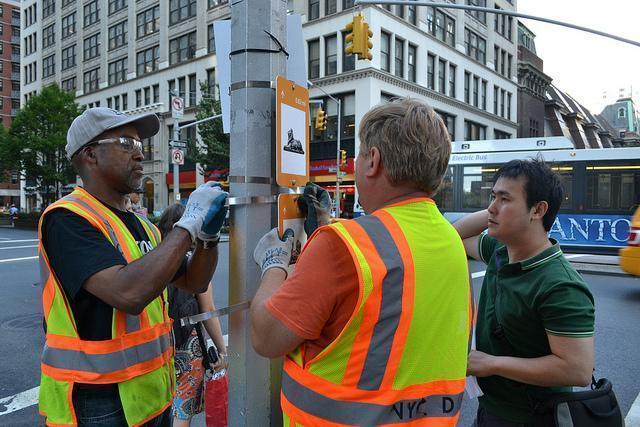What are the signs for?
Make your selection from the four choices given to correctly answer the question.
Options: Traffic signs, maps, selling stuff, missing dogs. Missing dogs. 